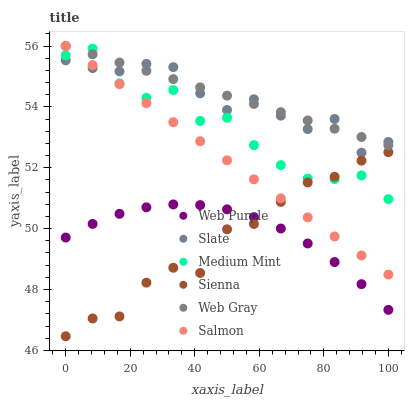Does Sienna have the minimum area under the curve?
Answer yes or no. Yes. Does Web Gray have the maximum area under the curve?
Answer yes or no. Yes. Does Slate have the minimum area under the curve?
Answer yes or no. No. Does Slate have the maximum area under the curve?
Answer yes or no. No. Is Salmon the smoothest?
Answer yes or no. Yes. Is Medium Mint the roughest?
Answer yes or no. Yes. Is Web Gray the smoothest?
Answer yes or no. No. Is Web Gray the roughest?
Answer yes or no. No. Does Sienna have the lowest value?
Answer yes or no. Yes. Does Slate have the lowest value?
Answer yes or no. No. Does Salmon have the highest value?
Answer yes or no. Yes. Does Slate have the highest value?
Answer yes or no. No. Is Sienna less than Web Gray?
Answer yes or no. Yes. Is Slate greater than Web Purple?
Answer yes or no. Yes. Does Slate intersect Web Gray?
Answer yes or no. Yes. Is Slate less than Web Gray?
Answer yes or no. No. Is Slate greater than Web Gray?
Answer yes or no. No. Does Sienna intersect Web Gray?
Answer yes or no. No. 